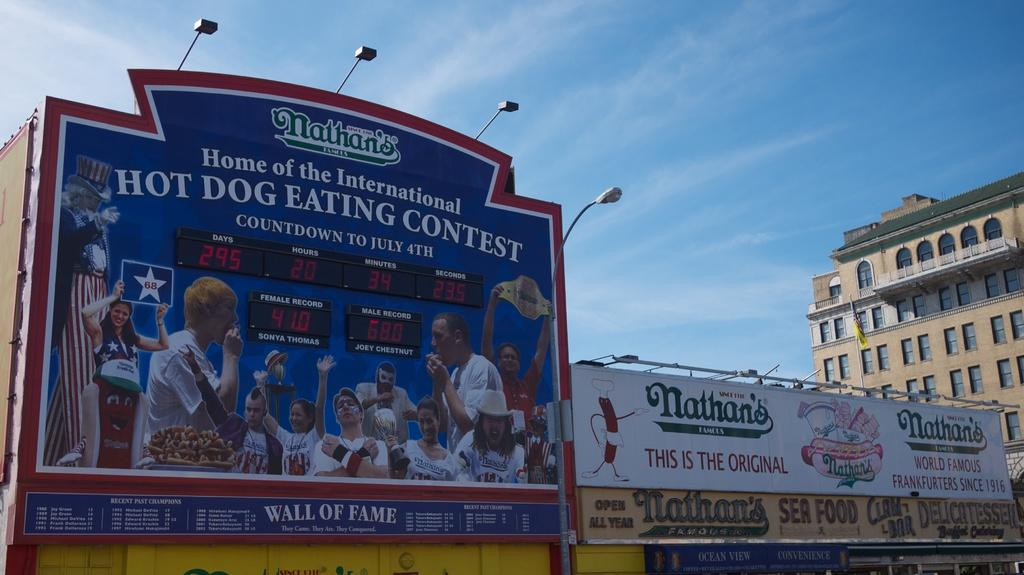<image>
Write a terse but informative summary of the picture. Sign at a baseball game that says Nathans Home of the International Hot Dog Eating Contest. 